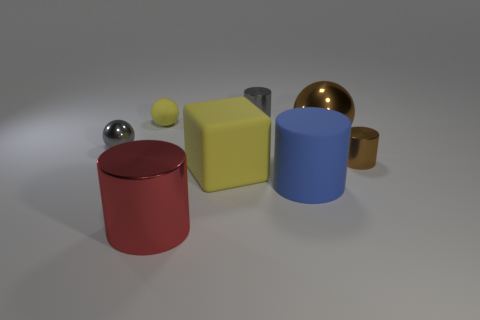Add 1 big brown cylinders. How many objects exist? 9 Subtract all spheres. How many objects are left? 5 Subtract all tiny brown balls. Subtract all brown metallic balls. How many objects are left? 7 Add 8 large shiny cylinders. How many large shiny cylinders are left? 9 Add 1 tiny yellow matte balls. How many tiny yellow matte balls exist? 2 Subtract 0 cyan blocks. How many objects are left? 8 